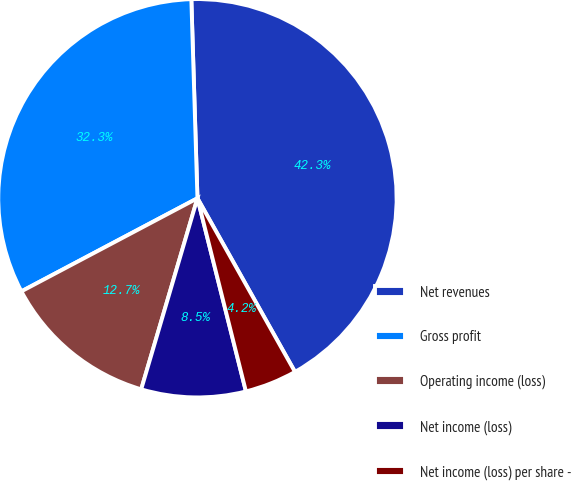Convert chart. <chart><loc_0><loc_0><loc_500><loc_500><pie_chart><fcel>Net revenues<fcel>Gross profit<fcel>Operating income (loss)<fcel>Net income (loss)<fcel>Net income (loss) per share -<nl><fcel>42.34%<fcel>32.25%<fcel>12.7%<fcel>8.47%<fcel>4.23%<nl></chart> 